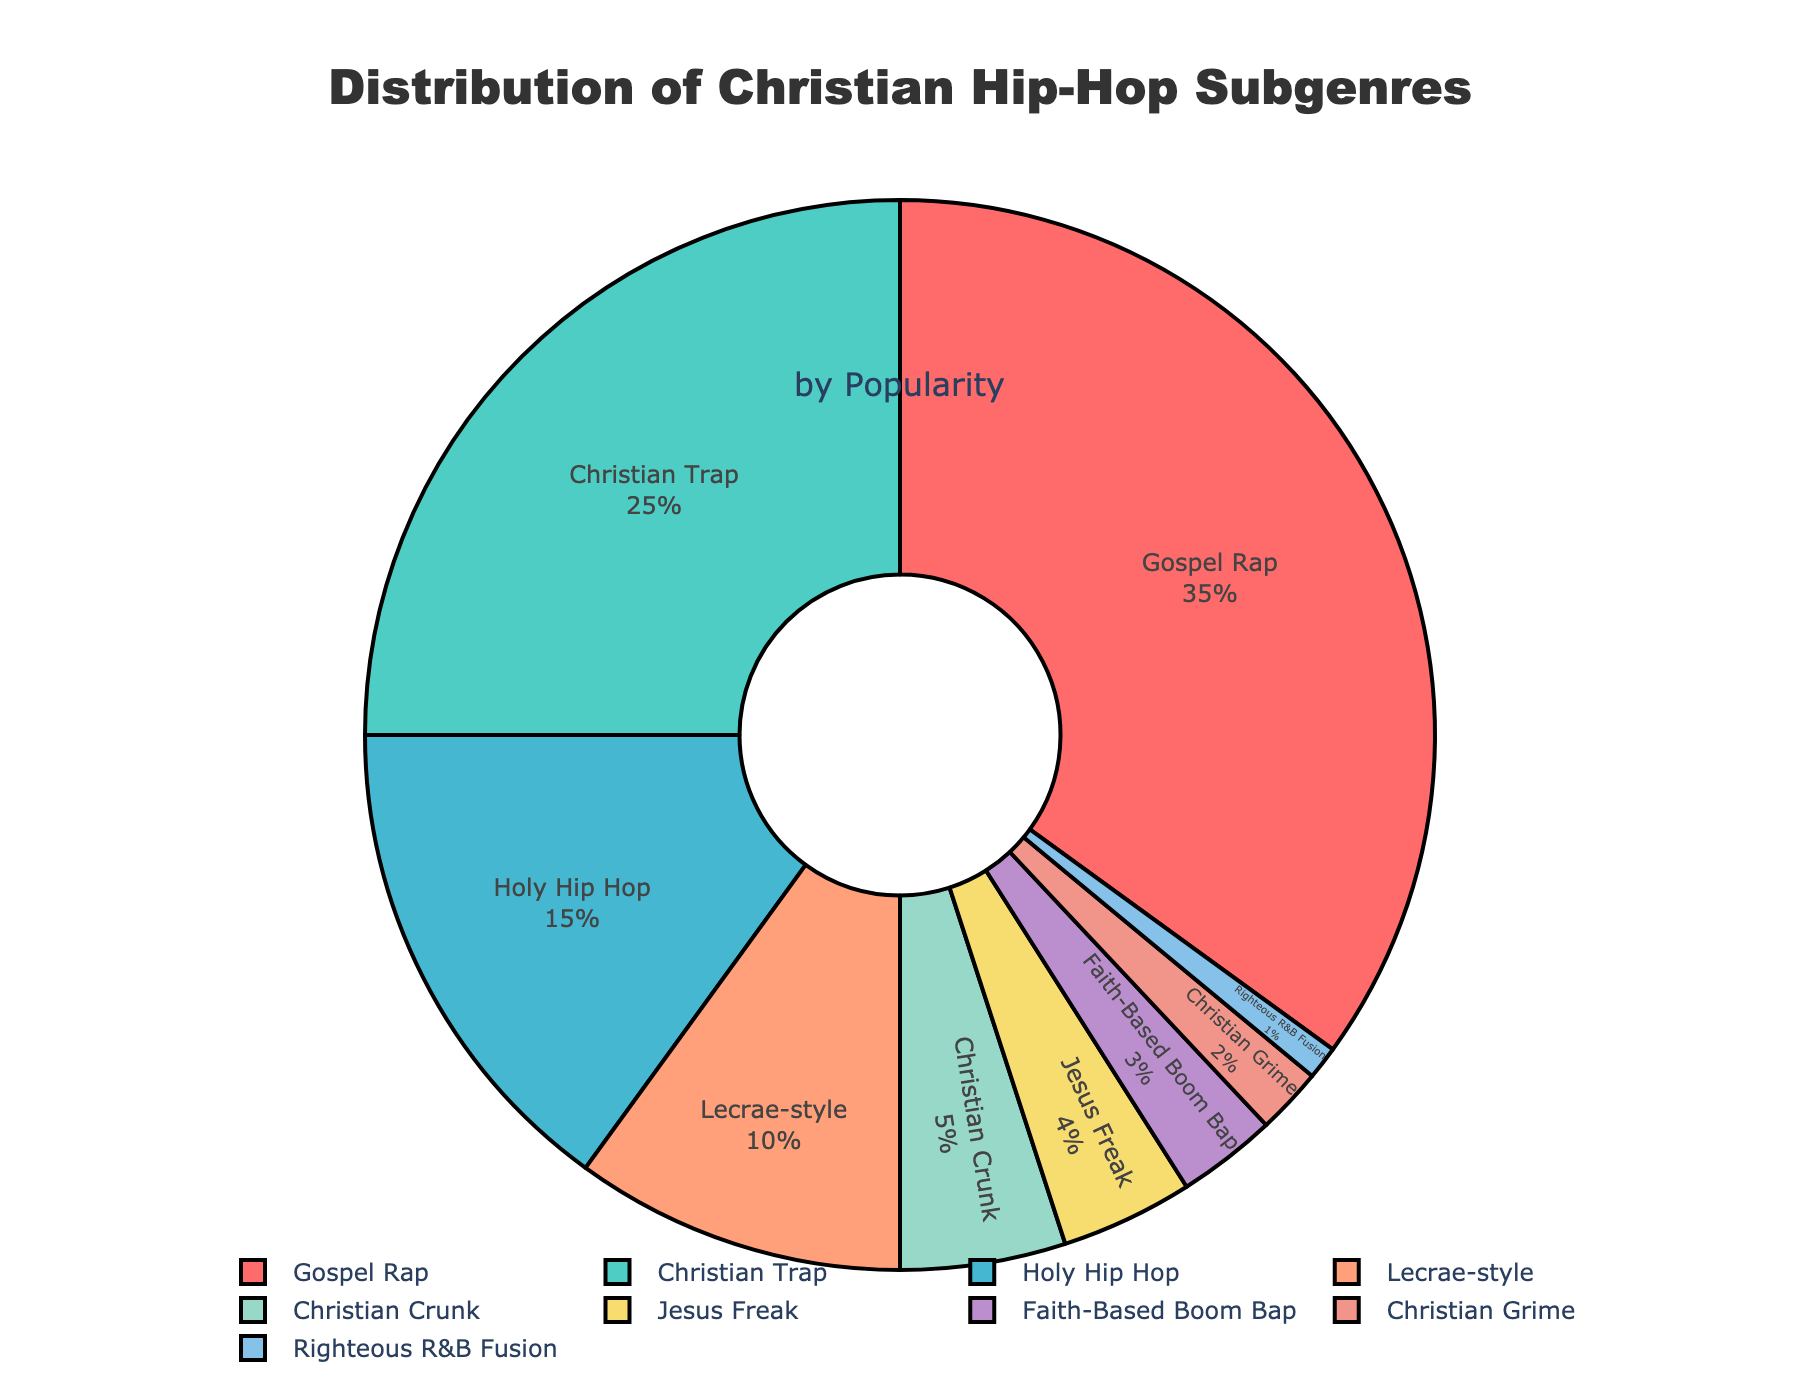Which Christian hip-hop subgenre is the most popular? Gospel Rap is the subgenre with the largest section of the pie chart, indicating it has the highest popularity (35%).
Answer: Gospel Rap What percentage of the total popularity does Christian Trap make up? The pie chart shows that Christian Trap accounts for 25% of the total popularity.
Answer: 25% Which two subgenres together make up exactly 50% of the total popularity? By checking the percentages on the pie chart, we see that Gospel Rap (35%) and Christian Trap (25%) together sum to 60%, not 50%. No two subgenres together make up 50%.
Answer: None List the subgenres with less than a 5% share of the total popularity. Checking the pie chart shows that Jesus Freak (4%), Faith-Based Boom Bap (3%), Christian Grime (2%), and Righteous R&B Fusion (1%) each have less than a 5% share.
Answer: Jesus Freak, Faith-Based Boom Bap, Christian Grime, Righteous R&B Fusion Is Lecrae-style more popular than Christian Crunk? By comparing their sections on the pie chart, Lecrae-style has 10% while Christian Crunk has 5%, making Lecrae-style more popular.
Answer: Yes What is the combined popularity percentage of Holy Hip Hop and Lecrae-style? Adding their percentages from the pie chart, Holy Hip Hop (15%) and Lecrae-style (10%) result in 25%.
Answer: 25% If Christian Trap's popularity increased by 10%, what would its new percentage be? Adding 10 percentage points to the current 25%, Christian Trap's new percentage would be 35%.
Answer: 35% Which subgenre has the smallest section in the pie chart? The pie chart indicates that Righteous R&B Fusion has the smallest section with 1% popularity.
Answer: Righteous R&B Fusion Is the popularity of Christian Trap greater than the combined popularity of Faith-Based Boom Bap, Christian Grime, and Righteous R&B Fusion? Adding Faith-Based Boom Bap (3%), Christian Grime (2%), and Righteous R&B Fusion (1%) results in 6%, which is less than Christian Trap's 25%.
Answer: Yes 